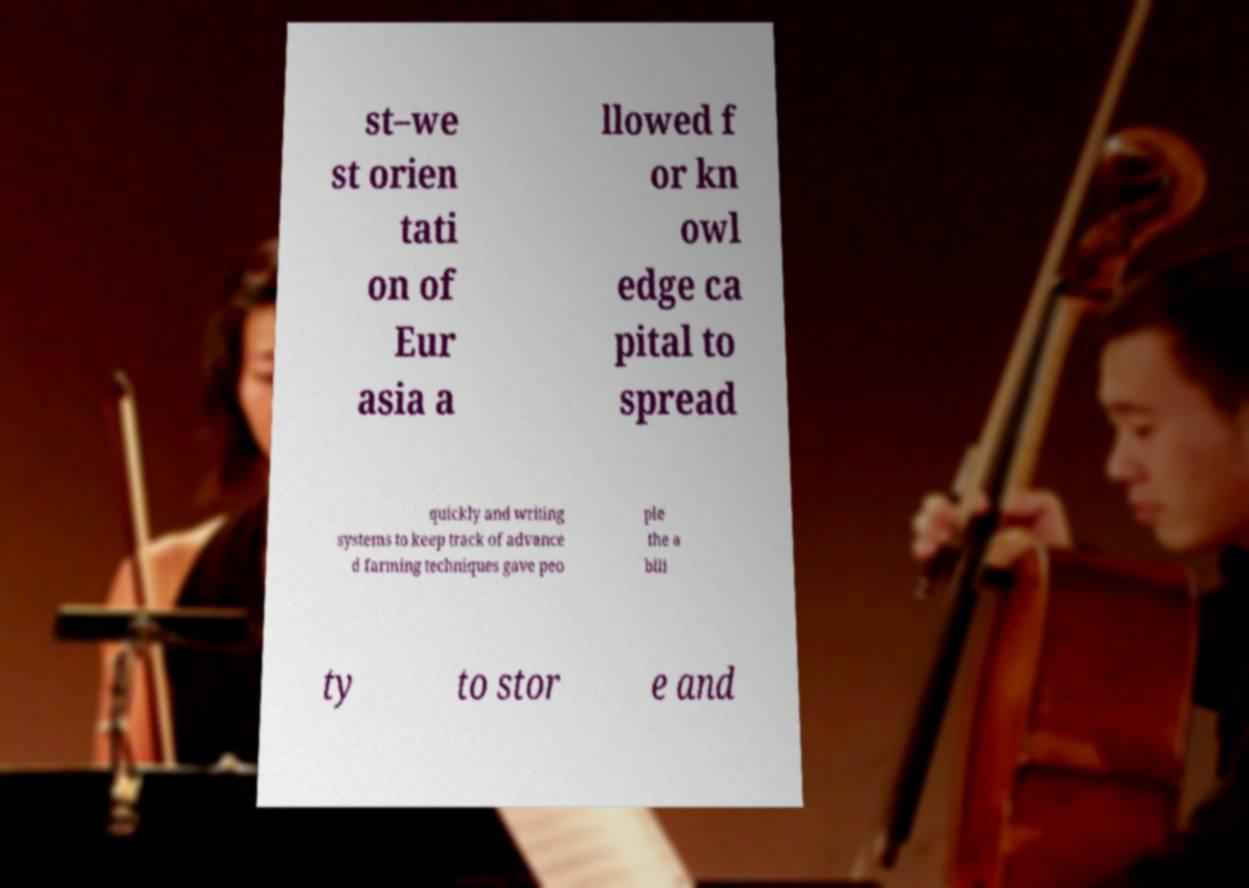There's text embedded in this image that I need extracted. Can you transcribe it verbatim? st–we st orien tati on of Eur asia a llowed f or kn owl edge ca pital to spread quickly and writing systems to keep track of advance d farming techniques gave peo ple the a bili ty to stor e and 